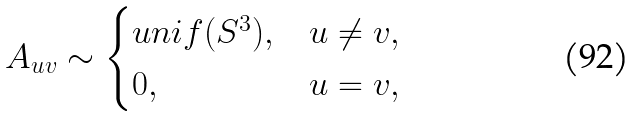Convert formula to latex. <formula><loc_0><loc_0><loc_500><loc_500>A _ { u v } \sim \begin{cases} u n i f ( S ^ { 3 } ) , & u \neq v , \\ 0 , & u = v , \end{cases}</formula> 